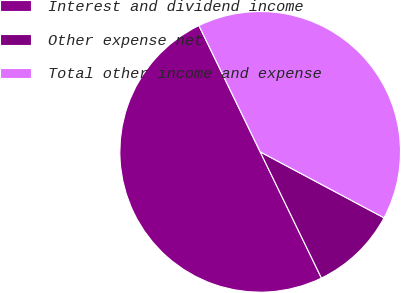<chart> <loc_0><loc_0><loc_500><loc_500><pie_chart><fcel>Interest and dividend income<fcel>Other expense net<fcel>Total other income and expense<nl><fcel>50.0%<fcel>10.02%<fcel>39.98%<nl></chart> 